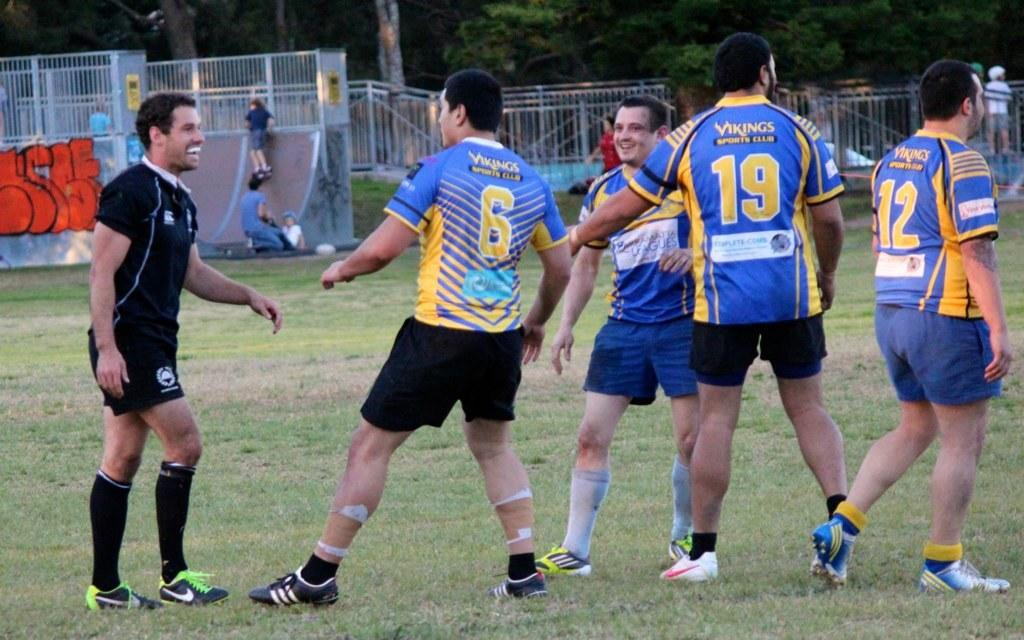What type of trees can be seen in the image? There are trees in the image, but the specific type of trees cannot be determined from the provided facts. What color is the grass on the ground in the image? The grass on the ground is green. What is present on the surface of the ground in the image? There are objects on the surface of the ground. What type of visual displays can be seen in the image? There are posters in the image. What are the people in the image doing with the objects they are holding? The people in the image are holding objects, but their actions or purpose cannot be determined from the provided facts. How many clocks are visible on the trees in the image? There are no clocks visible on the trees in the image. What type of taste does the green grass have in the image? The taste of the green grass cannot be determined from the image, as taste is not a visual characteristic. 